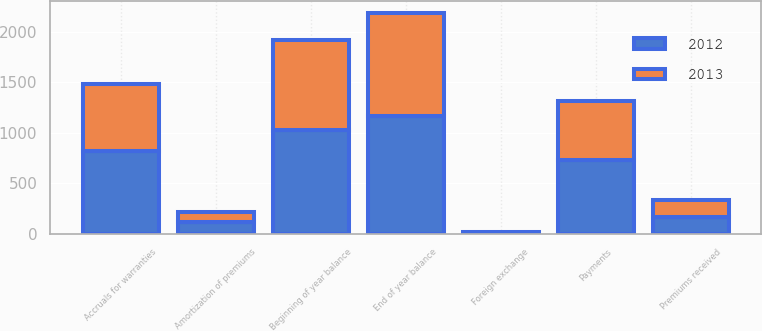Convert chart to OTSL. <chart><loc_0><loc_0><loc_500><loc_500><stacked_bar_chart><ecel><fcel>Beginning of year balance<fcel>Payments<fcel>Amortization of premiums<fcel>Accruals for warranties<fcel>Premiums received<fcel>Foreign exchange<fcel>End of year balance<nl><fcel>2012<fcel>1025<fcel>736<fcel>120<fcel>821<fcel>170<fcel>4<fcel>1164<nl><fcel>2013<fcel>892<fcel>580<fcel>100<fcel>666<fcel>164<fcel>17<fcel>1025<nl></chart> 